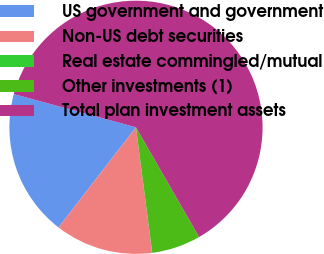Convert chart to OTSL. <chart><loc_0><loc_0><loc_500><loc_500><pie_chart><fcel>US government and government<fcel>Non-US debt securities<fcel>Real estate commingled/mutual<fcel>Other investments (1)<fcel>Total plan investment assets<nl><fcel>18.75%<fcel>12.51%<fcel>0.01%<fcel>6.26%<fcel>62.47%<nl></chart> 